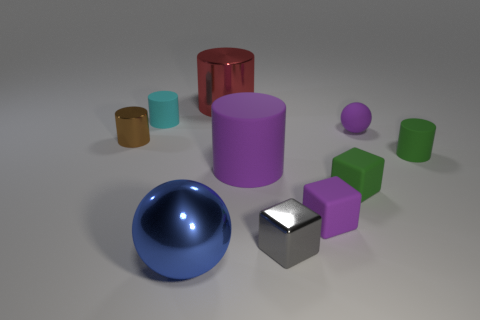What number of cylinders are either yellow metallic objects or small gray objects?
Give a very brief answer. 0. There is a small green rubber object that is in front of the purple matte cylinder; what is its shape?
Keep it short and to the point. Cube. What number of cyan objects have the same material as the small green cylinder?
Keep it short and to the point. 1. Is the number of small gray things to the right of the tiny gray object less than the number of small purple matte objects?
Offer a very short reply. Yes. There is a metallic thing that is on the left side of the ball in front of the large purple rubber thing; what size is it?
Ensure brevity in your answer.  Small. There is a tiny metal cylinder; does it have the same color as the rubber cylinder that is behind the small sphere?
Your answer should be compact. No. What is the material of the blue sphere that is the same size as the red metal object?
Ensure brevity in your answer.  Metal. Are there fewer tiny gray metal objects that are to the left of the gray block than big blue shiny spheres that are behind the brown thing?
Your answer should be compact. No. There is a shiny thing behind the object that is to the left of the small cyan rubber object; what shape is it?
Ensure brevity in your answer.  Cylinder. Is there a large purple rubber thing?
Keep it short and to the point. Yes. 